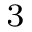Convert formula to latex. <formula><loc_0><loc_0><loc_500><loc_500>_ { 3 }</formula> 